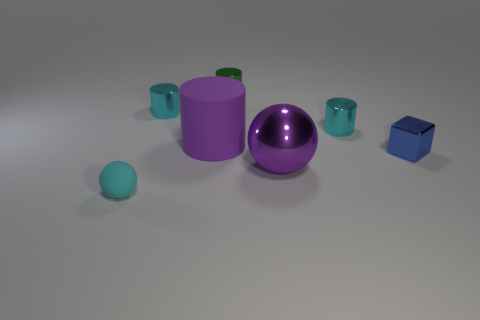Is there any other thing that is the same shape as the blue object?
Your answer should be compact. No. There is a tiny shiny thing that is both in front of the small green cylinder and to the left of the big sphere; what shape is it?
Offer a terse response. Cylinder. Does the cyan ball have the same size as the ball right of the green cylinder?
Offer a terse response. No. What color is the large rubber object that is the same shape as the green metal thing?
Provide a short and direct response. Purple. Does the ball that is behind the tiny matte thing have the same size as the cyan metal thing that is left of the green metallic thing?
Offer a very short reply. No. Does the purple metallic object have the same shape as the cyan matte thing?
Make the answer very short. Yes. What number of objects are big purple objects on the right side of the green thing or cyan rubber balls?
Offer a very short reply. 2. Is there a purple matte thing of the same shape as the small green metallic object?
Give a very brief answer. Yes. Are there the same number of big matte objects in front of the small blue cube and large metal spheres?
Ensure brevity in your answer.  No. What is the shape of the rubber object that is the same color as the big metallic thing?
Ensure brevity in your answer.  Cylinder. 